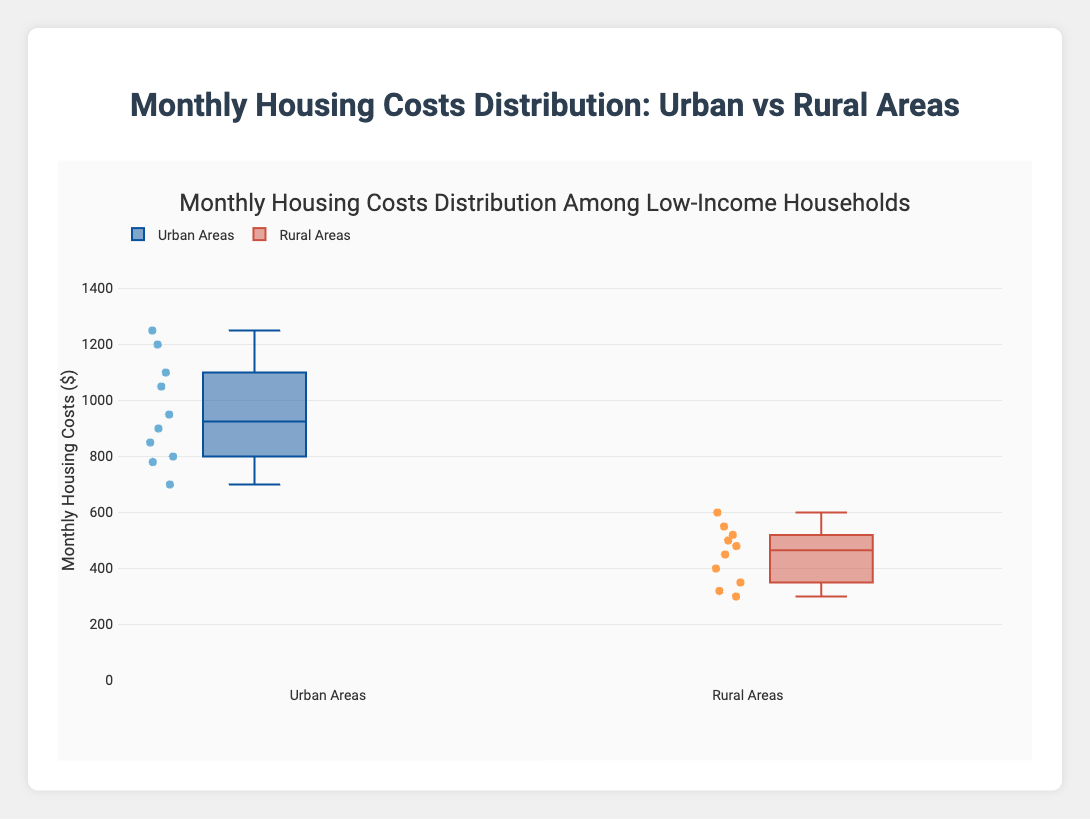What is the title of the plot? The title is at the top of the plot and provides a summary of what the plot is about.
Answer: Monthly Housing Costs Distribution Among Low-Income Households What are the two groups being compared in the box plot? The names of the groups are shown in the legend and the labels underneath each box.
Answer: Urban Areas and Rural Areas What is the highest monthly housing cost recorded in Urban Areas? Look for the highest data point in the box plot of Urban Areas.
Answer: $1250 Which area has the lowest housing cost, Urban or Rural Areas? Compare the lowest data points of the box plots for Urban and Rural Areas.
Answer: Rural Areas What is the median monthly housing cost for Rural Areas? The median is the line inside the box which divides the box into two equal parts for Rural Areas.
Answer: $460 How does the average of the upper quartile (75th percentile) compare between Urban and Rural Areas? The upper edge of the box represents the 75th percentile. Compare these values for both groups.
Answer: Higher in Urban Areas Which area shows more variability in housing costs, and how can you tell? Variability is indicated by the range between the minimum and maximum values (including outliers) and the interquartile range (IQR). Compare the distances in the box plots of both areas.
Answer: Urban Areas (greater spread between minimum and maximum) What are the interquartile ranges (IQR) for both Urban and Rural Areas? The IQR is the range between the upper quartile (75th percentile) and the lower quartile (25th percentile) in each box plot.
Answer: Urban: $250, Rural: $200 Is there any overlap between the monthly housing costs of Urban and Rural Areas? Check if the range of the box plot of Urban Areas overlaps with the range of the box plot of Rural Areas.
Answer: Yes What can you infer about the typical housing costs for low-income households in Urban compared to Rural Areas? Analyze the median, range, and any outliers present in both box plots to draw a comparison.
Answer: Urban Areas are higher and more variable 